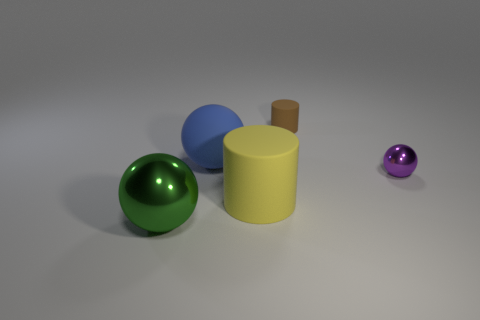Subtract all tiny balls. How many balls are left? 2 Add 4 gray shiny balls. How many objects exist? 9 Subtract all brown cylinders. How many cylinders are left? 1 Add 5 purple metal balls. How many purple metal balls exist? 6 Subtract 1 brown cylinders. How many objects are left? 4 Subtract all spheres. How many objects are left? 2 Subtract 1 cylinders. How many cylinders are left? 1 Subtract all green cylinders. Subtract all gray spheres. How many cylinders are left? 2 Subtract all large yellow matte balls. Subtract all cylinders. How many objects are left? 3 Add 3 tiny brown objects. How many tiny brown objects are left? 4 